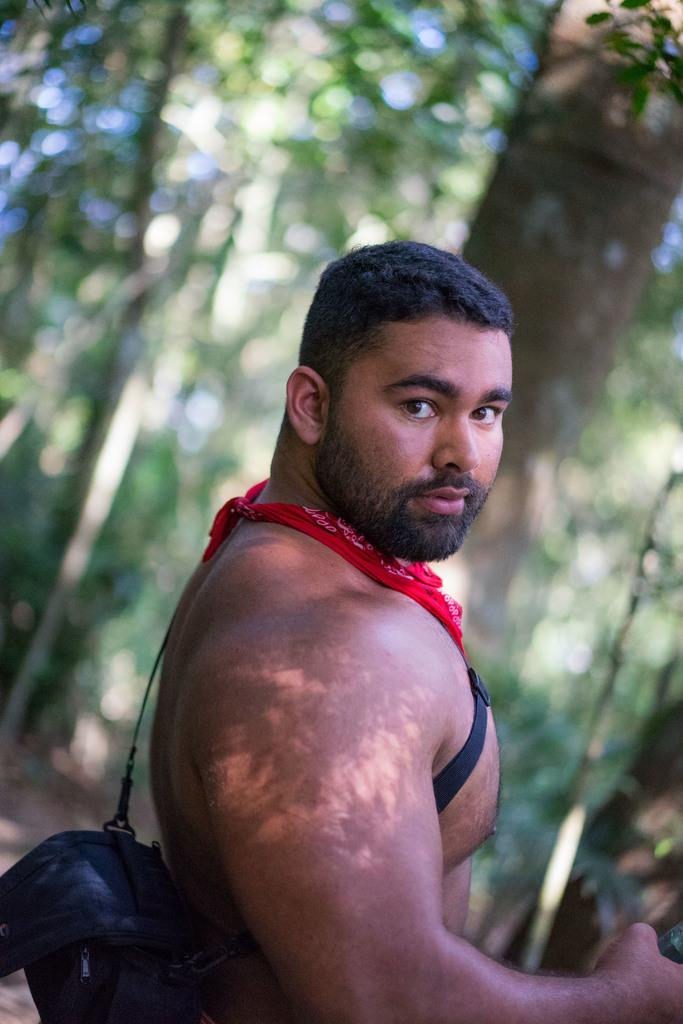What is the main subject of the image? There is a person in the image. What is the person wearing on their body? The person is wearing a black color bag. What other color is present in the person's attire? The person has a red color cloth. What can be seen in the background of the image? There are many trees in the background of the image, but they are blurry. Can you tell me how many baskets are hanging from the trees in the image? There are no baskets visible in the image; it only features a person and blurry trees in the background. 